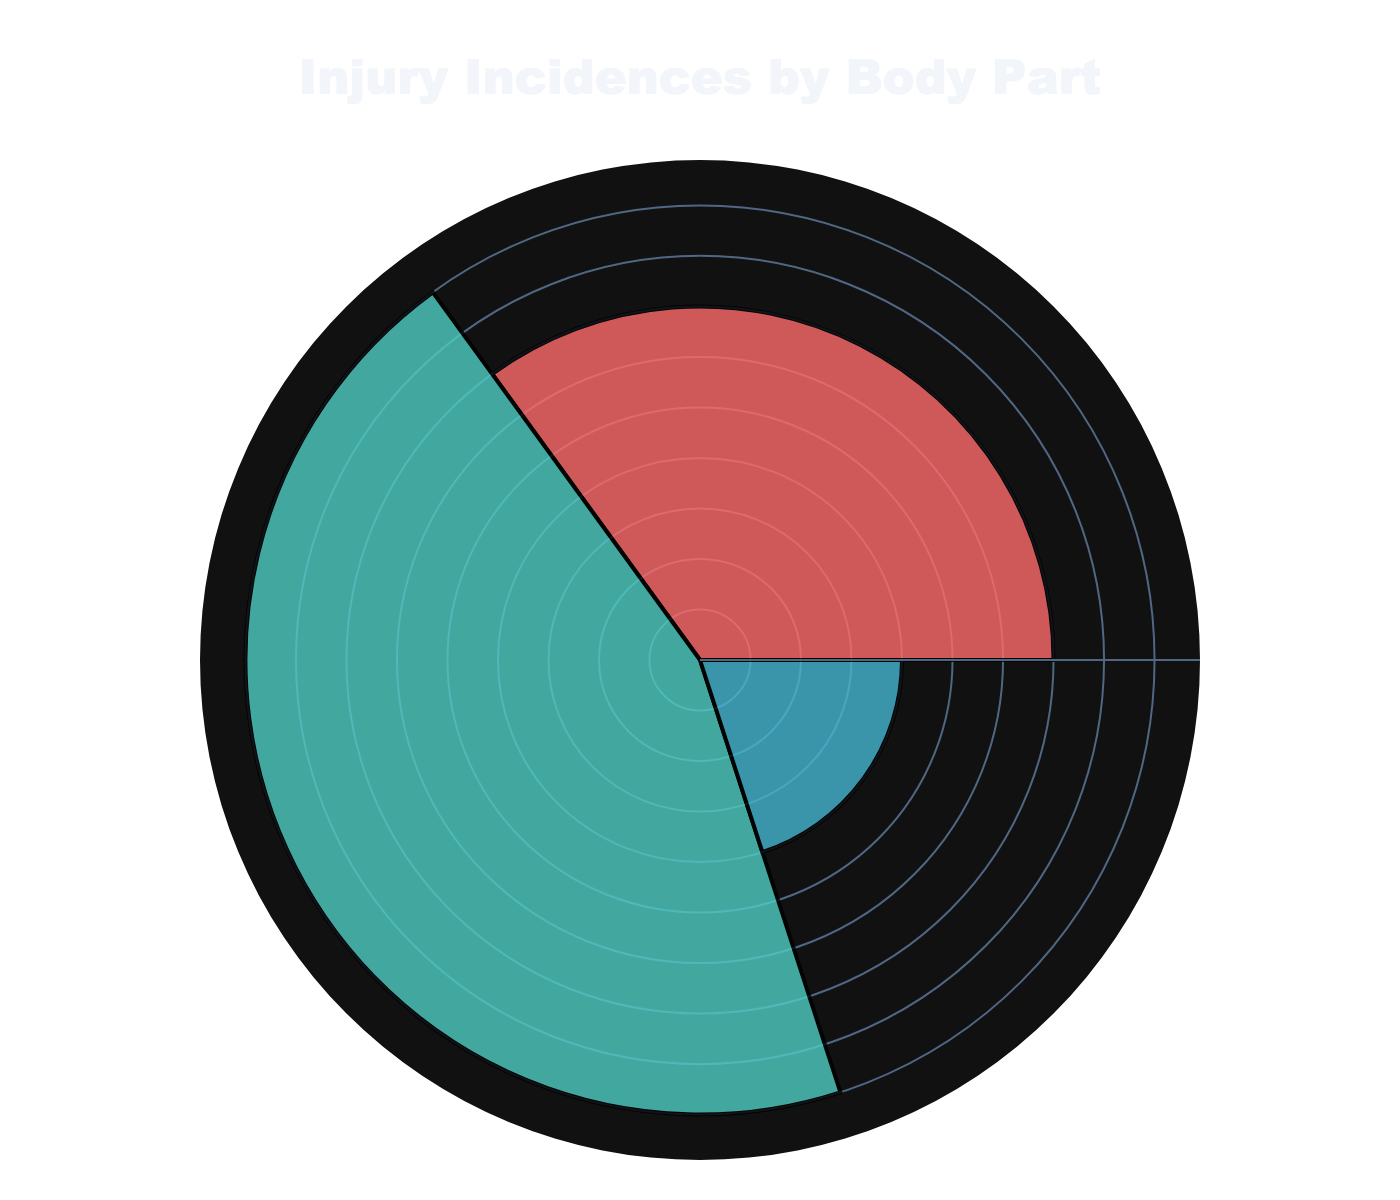What's the title of the chart? The title of the chart can be located at the top center of the figure. It typically provides a summary or overall description of what the chart represents. In this case, it is "Injury Incidences by Body Part".
Answer: Injury Incidences by Body Part How many body parts are represented in the chart? By counting the distinct sections of the chart, each labeled with different body parts, we see there are three groups: Ankle, Knee, and Hip.
Answer: 3 Which body part has the highest number of injury incidences? By examining the length of each section (bar), the group with the largest radius represents the highest number of incidences. Here, the Knee has the highest value, appearing larger than the Ankle and Hip.
Answer: Knee How many more injury incidences are there in the Knee compared to the Ankle? First, identify the injury incidences for the Knee (45) and Ankle (35). Subtract the Ankle incidences from the Knee incidences: 45 - 35 = 10.
Answer: 10 What's the total number of injury incidences represented in the chart? Add the incidences from all body parts: Ankle (35) + Knee (45) + Hip (20) = 100 incidences.
Answer: 100 What's the percentage of injury incidences for the Hip? Divide the number of Hip incidences (20) by the total number of incidences (100) and multiply by 100 to convert to a percentage: (20 / 100) * 100 = 20%.
Answer: 20% Rank the body parts by the number of injury incidences starting from the highest. Identify and list the incidences in descending order: Knee (45), Ankle (35), and Hip (20).
Answer: Knee, Ankle, Hip Which two body parts combined have fewer injury incidences than the Knee? Add the incidences of each pair: Ankle (35) + Hip (20) = 55, which is more than the Knee, so only Knee and Hip (45 + 20 = 65) combination has fewer incidences than the Knee alone.
Answer: Ankle and Hip 